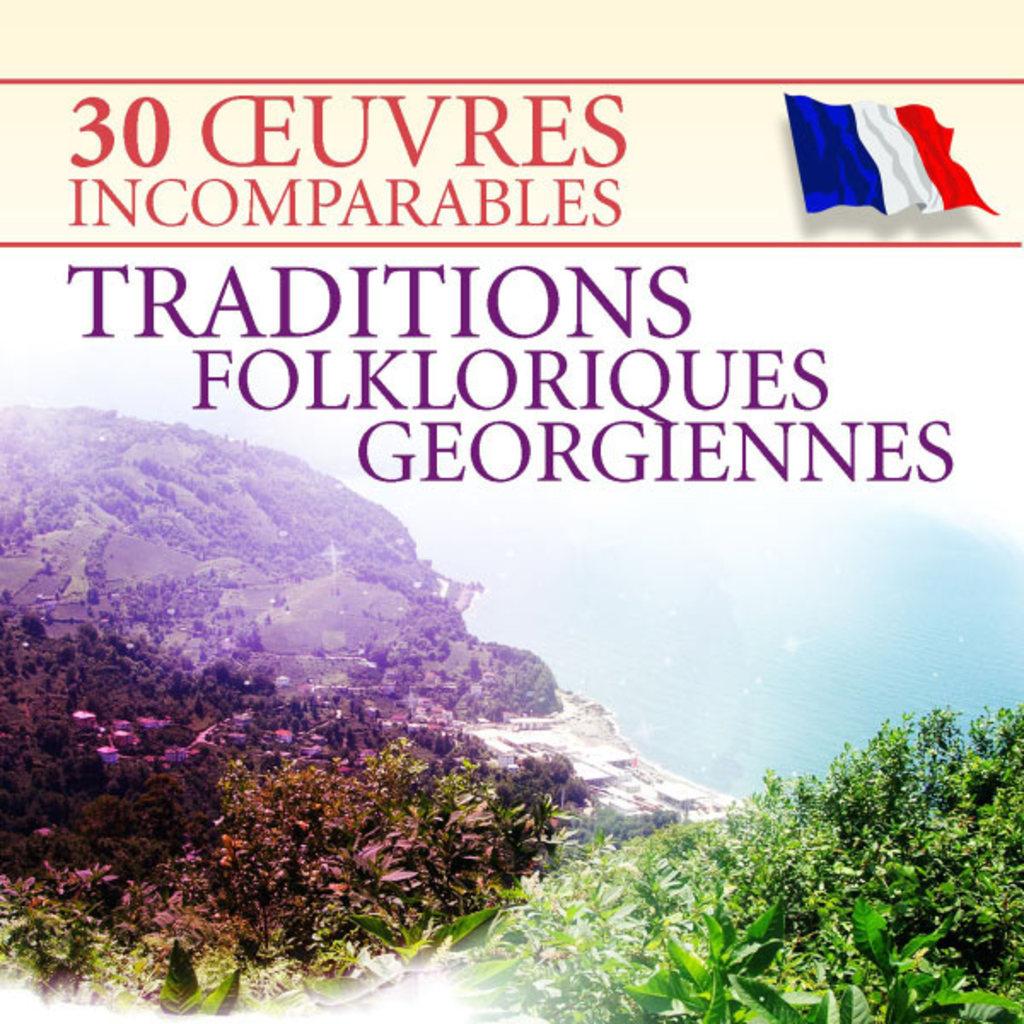What is the name of the book?
Give a very brief answer. Traditions folkloriques georgiennes. What is the name of magazine/?
Ensure brevity in your answer.  Traditions. 